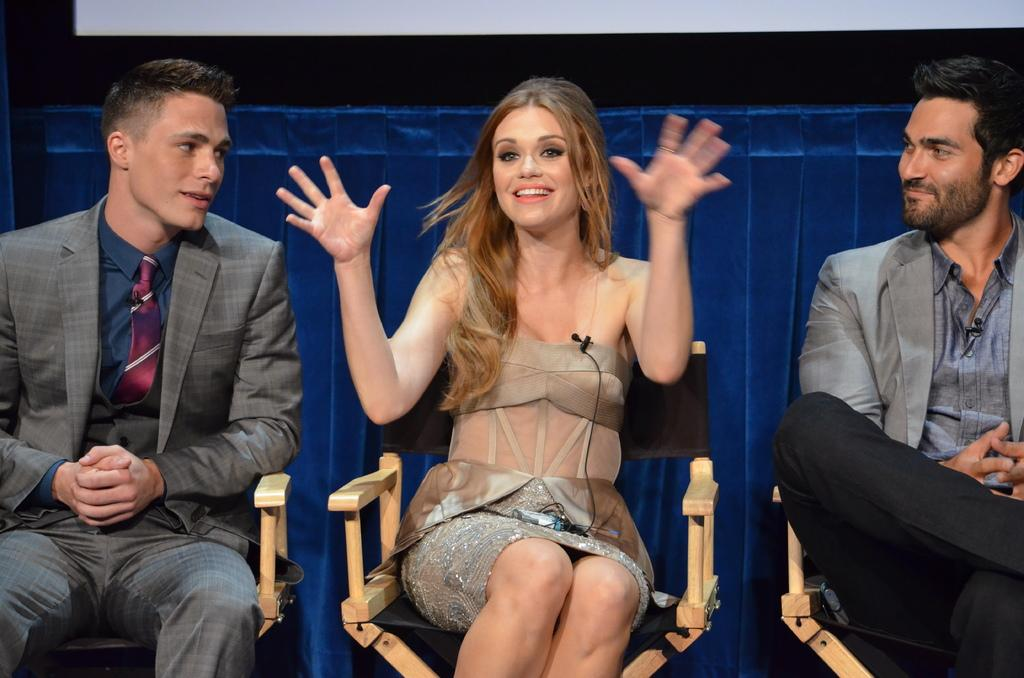How many people are in the image? There are three people in the image. What are the people doing in the image? The people are sitting on chairs. What is the woman in the image doing? The woman is explaining something. What can be seen behind the people in the image? There are objects visible behind the people. What type of butter is being used to celebrate the holiday in the image? There is no butter or holiday mentioned or depicted in the image. 